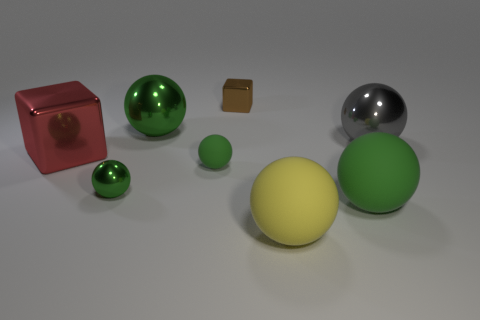Subtract all blue cylinders. How many green balls are left? 4 Subtract 2 spheres. How many spheres are left? 4 Subtract all gray balls. How many balls are left? 5 Subtract all small balls. How many balls are left? 4 Subtract all purple spheres. Subtract all green blocks. How many spheres are left? 6 Add 2 small red spheres. How many objects exist? 10 Subtract all balls. How many objects are left? 2 Subtract 0 yellow cylinders. How many objects are left? 8 Subtract all large gray objects. Subtract all brown matte objects. How many objects are left? 7 Add 7 yellow rubber balls. How many yellow rubber balls are left? 8 